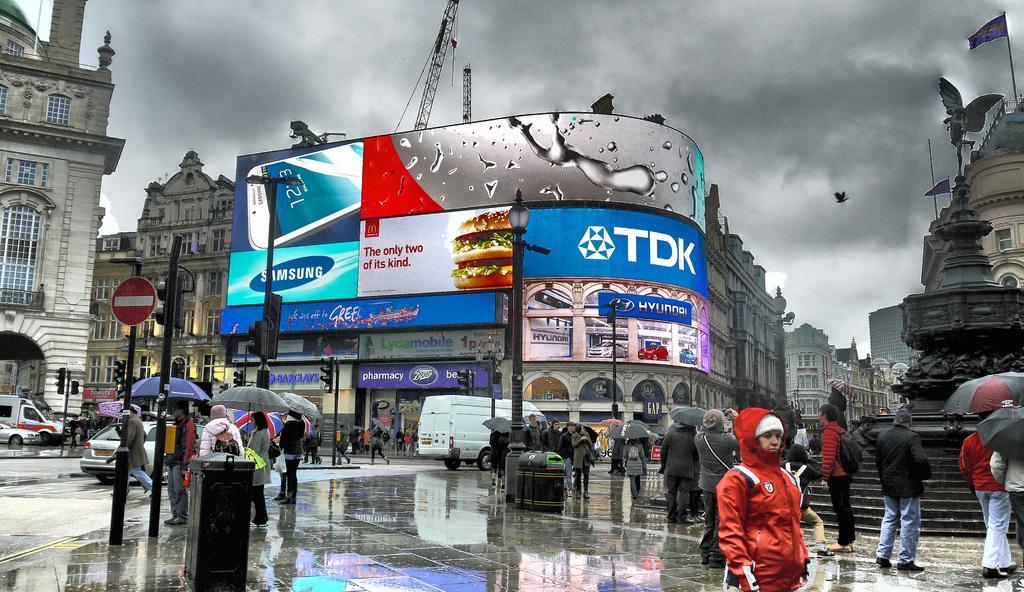Please provide a concise description of this image. In this image we can see some people standing on the wet road holding the umbrellas. We can also see traffic lights, street pole, sign broad, a pole, building with windows and some vehicles. On the right side we can see a building with statue, windows, stairs and a flag. On the backside we can see a crane, a bird and the sky which looks cloudy. 